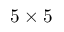Convert formula to latex. <formula><loc_0><loc_0><loc_500><loc_500>5 \times 5</formula> 